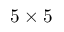Convert formula to latex. <formula><loc_0><loc_0><loc_500><loc_500>5 \times 5</formula> 